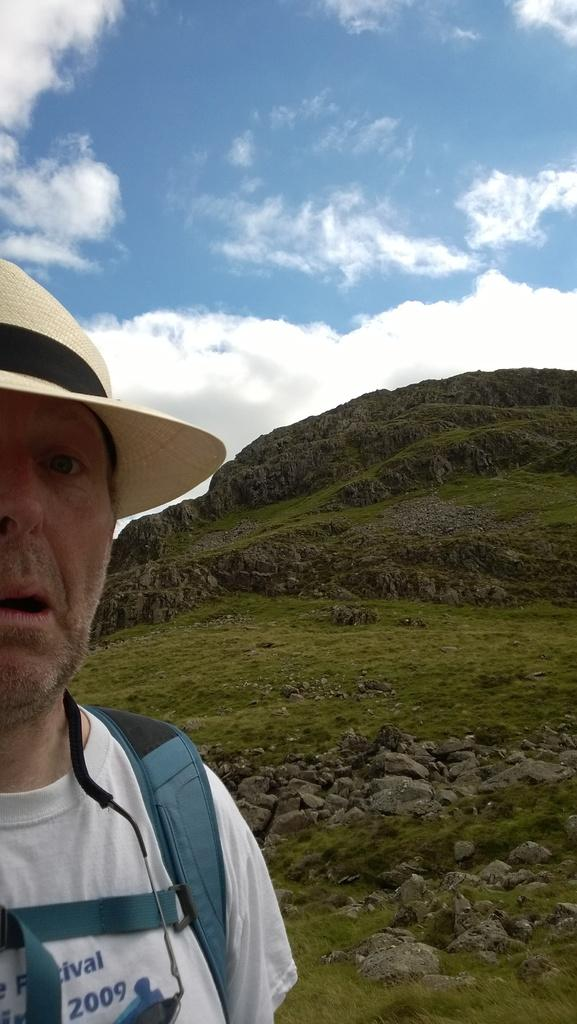What is the main subject of the image? There is a man in the image. What is the man wearing on his head? The man is wearing a hat. What is the man carrying in the image? The man is carrying a bag. What type of natural environment is visible in the background of the image? There are stones and grass visible in the background of the image. What is visible at the top of the image? The sky is visible at the top of the image. What type of coach can be seen in the image? There is no coach present in the image. How many thumbs does the man have in the image? The image does not show the man's hands, so it is impossible to determine the number of thumbs he has. 